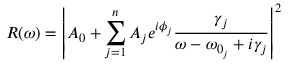Convert formula to latex. <formula><loc_0><loc_0><loc_500><loc_500>R ( \omega ) = \left | A _ { 0 } + \sum _ { j = 1 } ^ { n } A _ { j } e ^ { i \phi _ { j } } \frac { \gamma _ { j } } { \omega - \omega _ { 0 _ { j } } + i \gamma _ { j } } \right | ^ { 2 }</formula> 